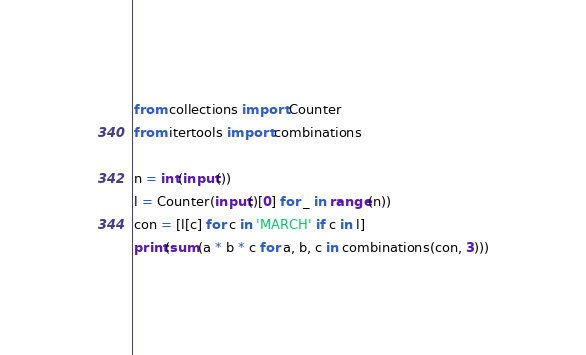<code> <loc_0><loc_0><loc_500><loc_500><_Python_>from collections import Counter
from itertools import combinations

n = int(input())
l = Counter(input()[0] for _ in range(n))
con = [l[c] for c in 'MARCH' if c in l]
print(sum(a * b * c for a, b, c in combinations(con, 3)))
</code> 